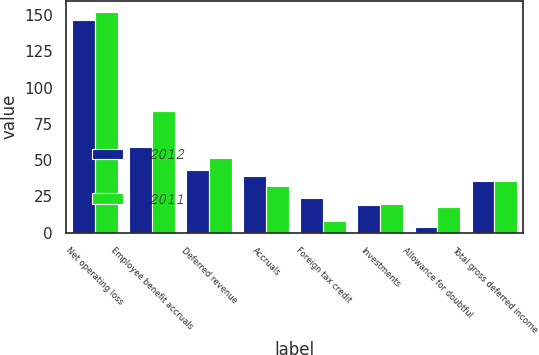<chart> <loc_0><loc_0><loc_500><loc_500><stacked_bar_chart><ecel><fcel>Net operating loss<fcel>Employee benefit accruals<fcel>Deferred revenue<fcel>Accruals<fcel>Foreign tax credit<fcel>Investments<fcel>Allowance for doubtful<fcel>Total gross deferred income<nl><fcel>2012<fcel>146.7<fcel>59.3<fcel>43.5<fcel>39<fcel>23.8<fcel>19.2<fcel>3.7<fcel>35.6<nl><fcel>2011<fcel>152.2<fcel>83.8<fcel>51.5<fcel>32.2<fcel>8.3<fcel>19.9<fcel>17.8<fcel>35.6<nl></chart> 